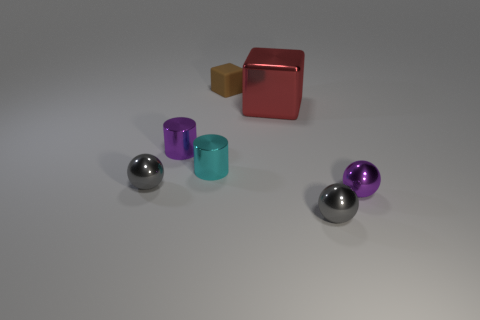Add 1 brown cylinders. How many objects exist? 8 Subtract all blocks. How many objects are left? 5 Subtract 0 green cylinders. How many objects are left? 7 Subtract all brown rubber blocks. Subtract all large red shiny things. How many objects are left? 5 Add 7 metallic cylinders. How many metallic cylinders are left? 9 Add 4 small blocks. How many small blocks exist? 5 